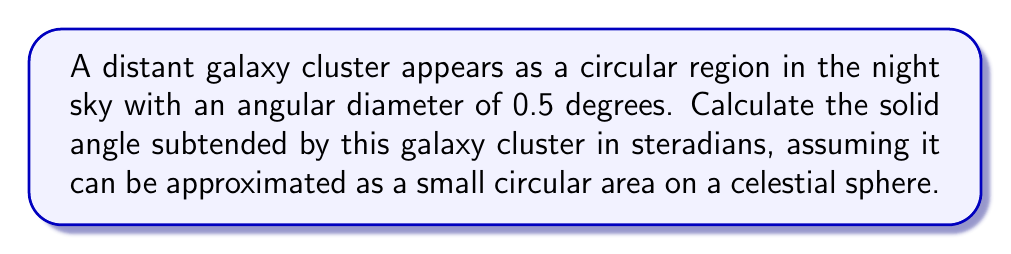Teach me how to tackle this problem. To calculate the solid angle subtended by the galaxy cluster, we'll follow these steps:

1) The formula for solid angle $\Omega$ of a small circular area on a sphere is:

   $$\Omega = 2\pi(1 - \cos(\theta/2))$$

   where $\theta$ is the angular diameter in radians.

2) We're given the angular diameter in degrees, so we need to convert it to radians:

   $$\theta = 0.5° \times \frac{\pi}{180°} = \frac{\pi}{360} \text{ radians}$$

3) Now we can substitute this into our formula:

   $$\Omega = 2\pi(1 - \cos(\frac{\pi}{720}))$$

4) Using a calculator or computer to evaluate this:

   $$\Omega \approx 2\pi(1 - 0.99999880)$$
   $$\Omega \approx 2\pi(0.00000120)$$
   $$\Omega \approx 0.00000754 \text{ steradians}$$

5) This can be expressed in scientific notation as:

   $$\Omega \approx 7.54 \times 10^{-6} \text{ steradians}$$
Answer: $7.54 \times 10^{-6}$ sr 